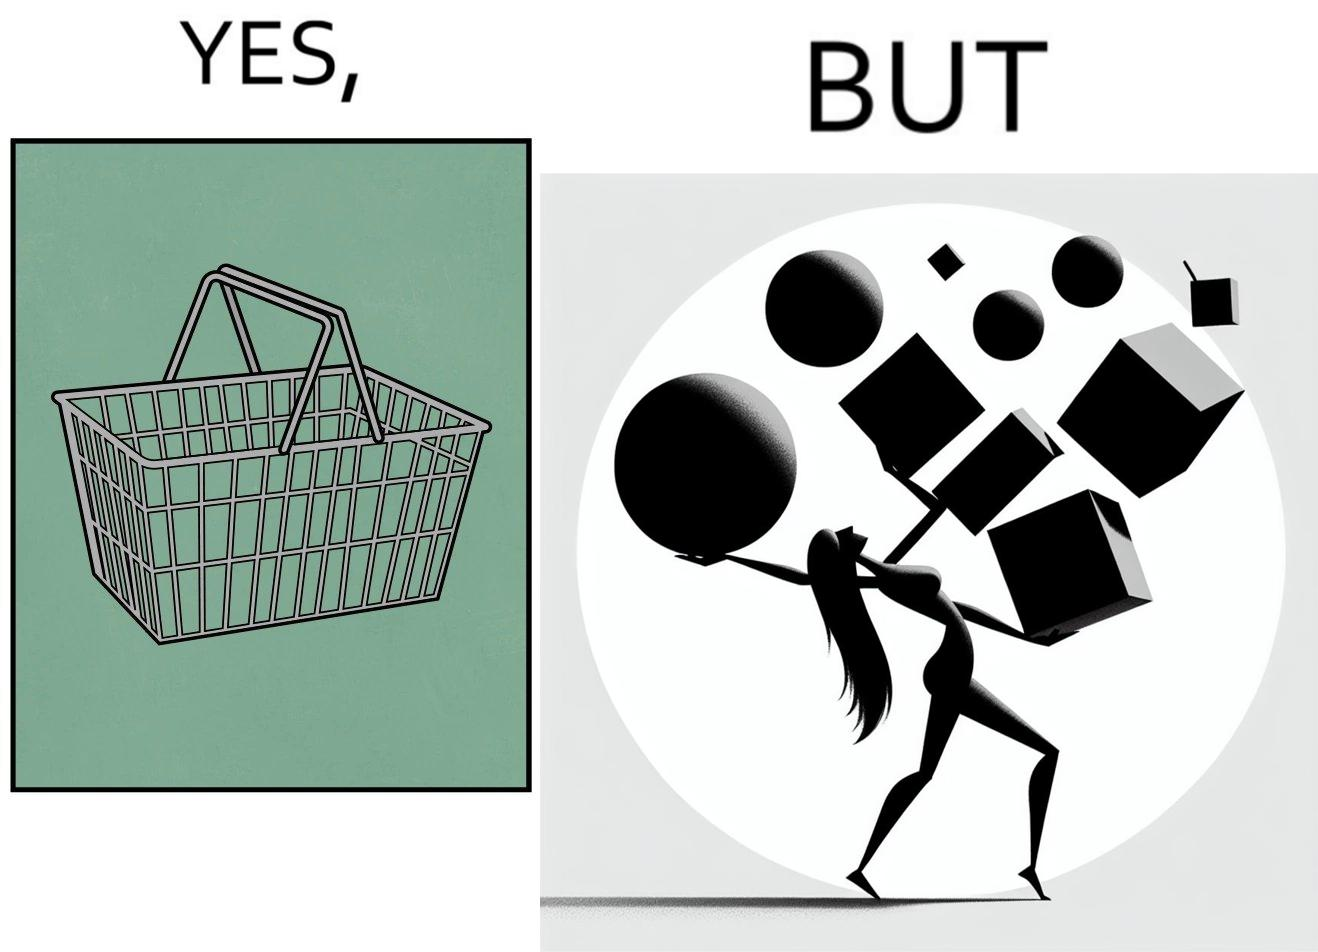Is this a satirical image? Yes, this image is satirical. 